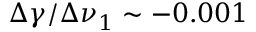<formula> <loc_0><loc_0><loc_500><loc_500>\Delta \gamma / \Delta \nu _ { 1 } \sim - 0 . 0 0 1</formula> 